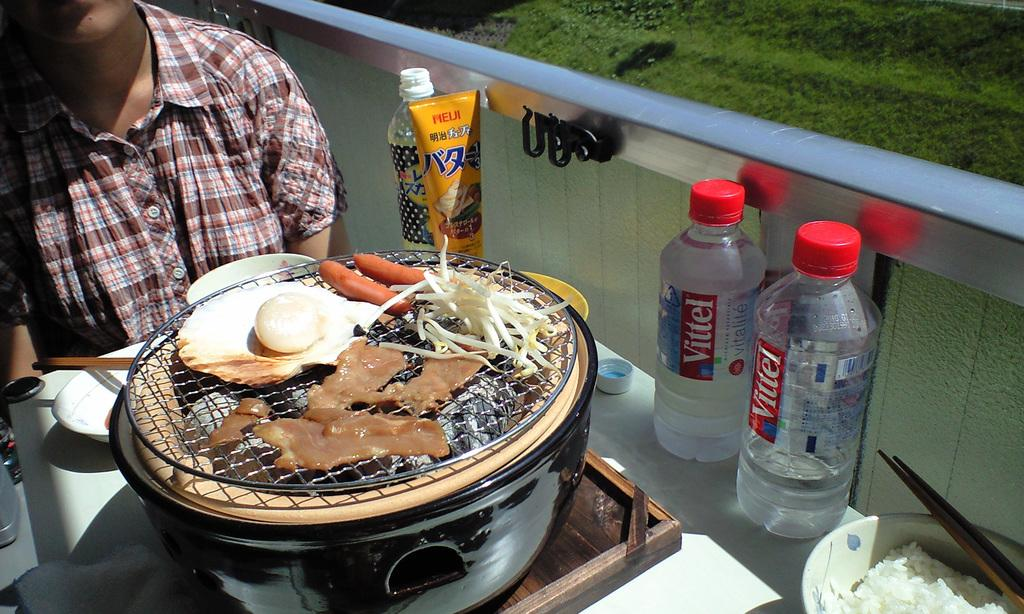Provide a one-sentence caption for the provided image. Two Vittel waters sit next to some cooking food. 